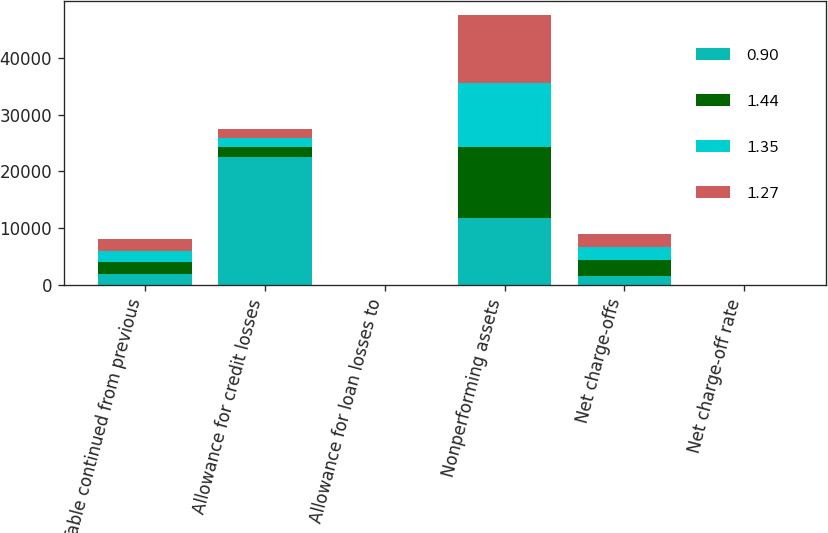Convert chart to OTSL. <chart><loc_0><loc_0><loc_500><loc_500><stacked_bar_chart><ecel><fcel>(Table continued from previous<fcel>Allowance for credit losses<fcel>Allowance for loan losses to<fcel>Nonperforming assets<fcel>Net charge-offs<fcel>Net charge-off rate<nl><fcel>0.9<fcel>2012<fcel>22604<fcel>2.43<fcel>11734<fcel>1628<fcel>0.9<nl><fcel>1.44<fcel>2012<fcel>1628<fcel>2.61<fcel>12481<fcel>2770<fcel>1.53<nl><fcel>1.35<fcel>2012<fcel>1628<fcel>2.74<fcel>11397<fcel>2278<fcel>1.27<nl><fcel>1.27<fcel>2012<fcel>1628<fcel>3.11<fcel>11953<fcel>2387<fcel>1.35<nl></chart> 